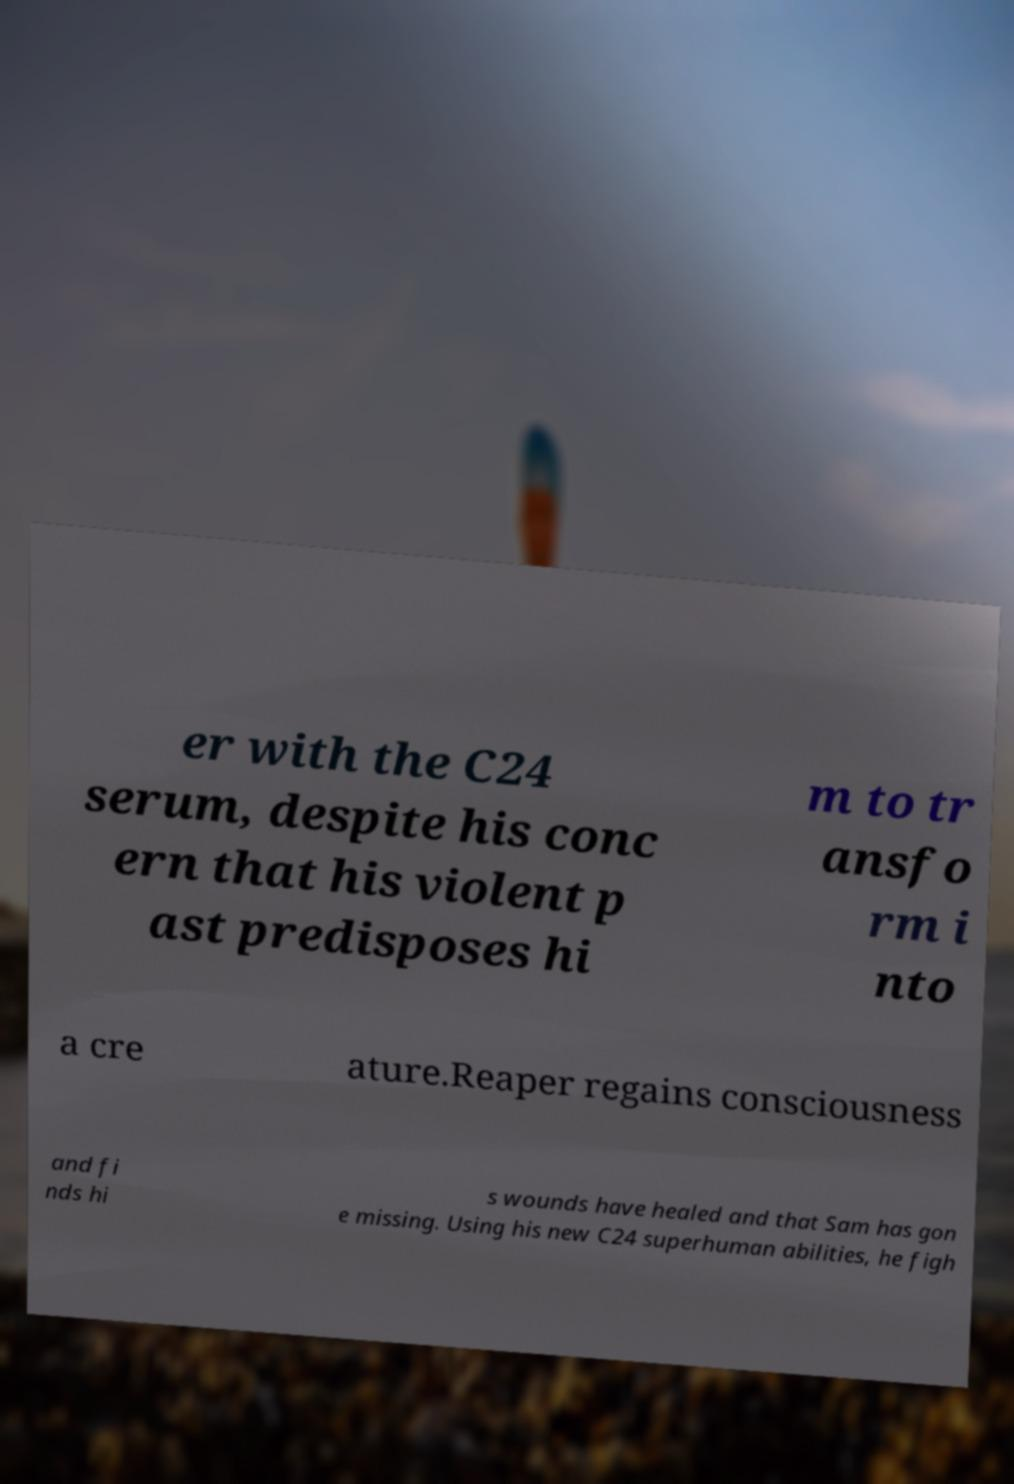Could you extract and type out the text from this image? er with the C24 serum, despite his conc ern that his violent p ast predisposes hi m to tr ansfo rm i nto a cre ature.Reaper regains consciousness and fi nds hi s wounds have healed and that Sam has gon e missing. Using his new C24 superhuman abilities, he figh 